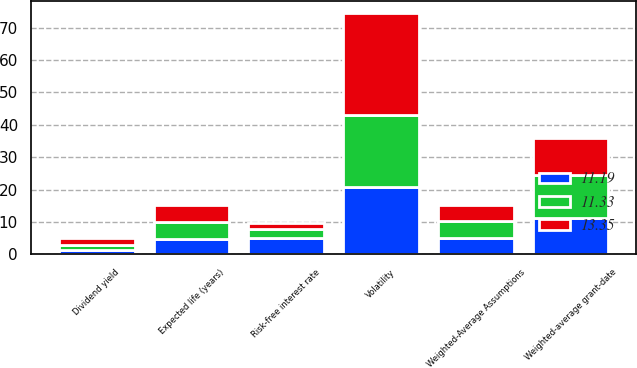Convert chart to OTSL. <chart><loc_0><loc_0><loc_500><loc_500><stacked_bar_chart><ecel><fcel>Weighted-Average Assumptions<fcel>Risk-free interest rate<fcel>Dividend yield<fcel>Expected life (years)<fcel>Volatility<fcel>Weighted-average grant-date<nl><fcel>13.35<fcel>5.1<fcel>1.9<fcel>2.3<fcel>5.1<fcel>31.3<fcel>11.33<nl><fcel>11.33<fcel>5.1<fcel>2.8<fcel>1.4<fcel>5.3<fcel>22.2<fcel>13.35<nl><fcel>11.19<fcel>5.1<fcel>4.9<fcel>1.4<fcel>4.7<fcel>20.9<fcel>11.19<nl></chart> 